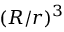Convert formula to latex. <formula><loc_0><loc_0><loc_500><loc_500>( R / r ) ^ { 3 }</formula> 